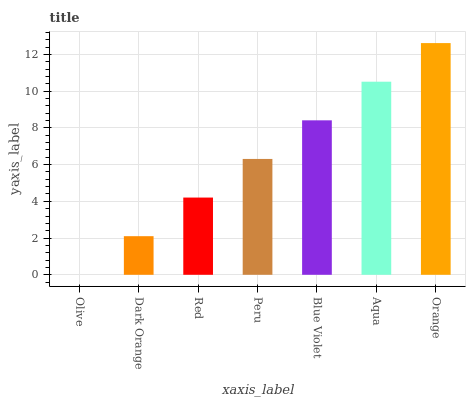Is Olive the minimum?
Answer yes or no. Yes. Is Orange the maximum?
Answer yes or no. Yes. Is Dark Orange the minimum?
Answer yes or no. No. Is Dark Orange the maximum?
Answer yes or no. No. Is Dark Orange greater than Olive?
Answer yes or no. Yes. Is Olive less than Dark Orange?
Answer yes or no. Yes. Is Olive greater than Dark Orange?
Answer yes or no. No. Is Dark Orange less than Olive?
Answer yes or no. No. Is Peru the high median?
Answer yes or no. Yes. Is Peru the low median?
Answer yes or no. Yes. Is Aqua the high median?
Answer yes or no. No. Is Dark Orange the low median?
Answer yes or no. No. 